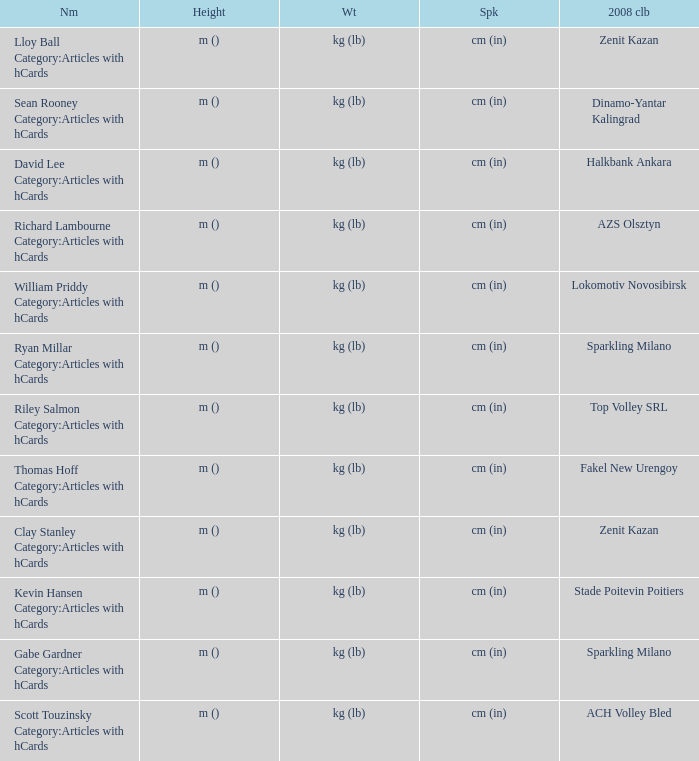What is the spike for the 2008 club of Lokomotiv Novosibirsk? Cm (in). 